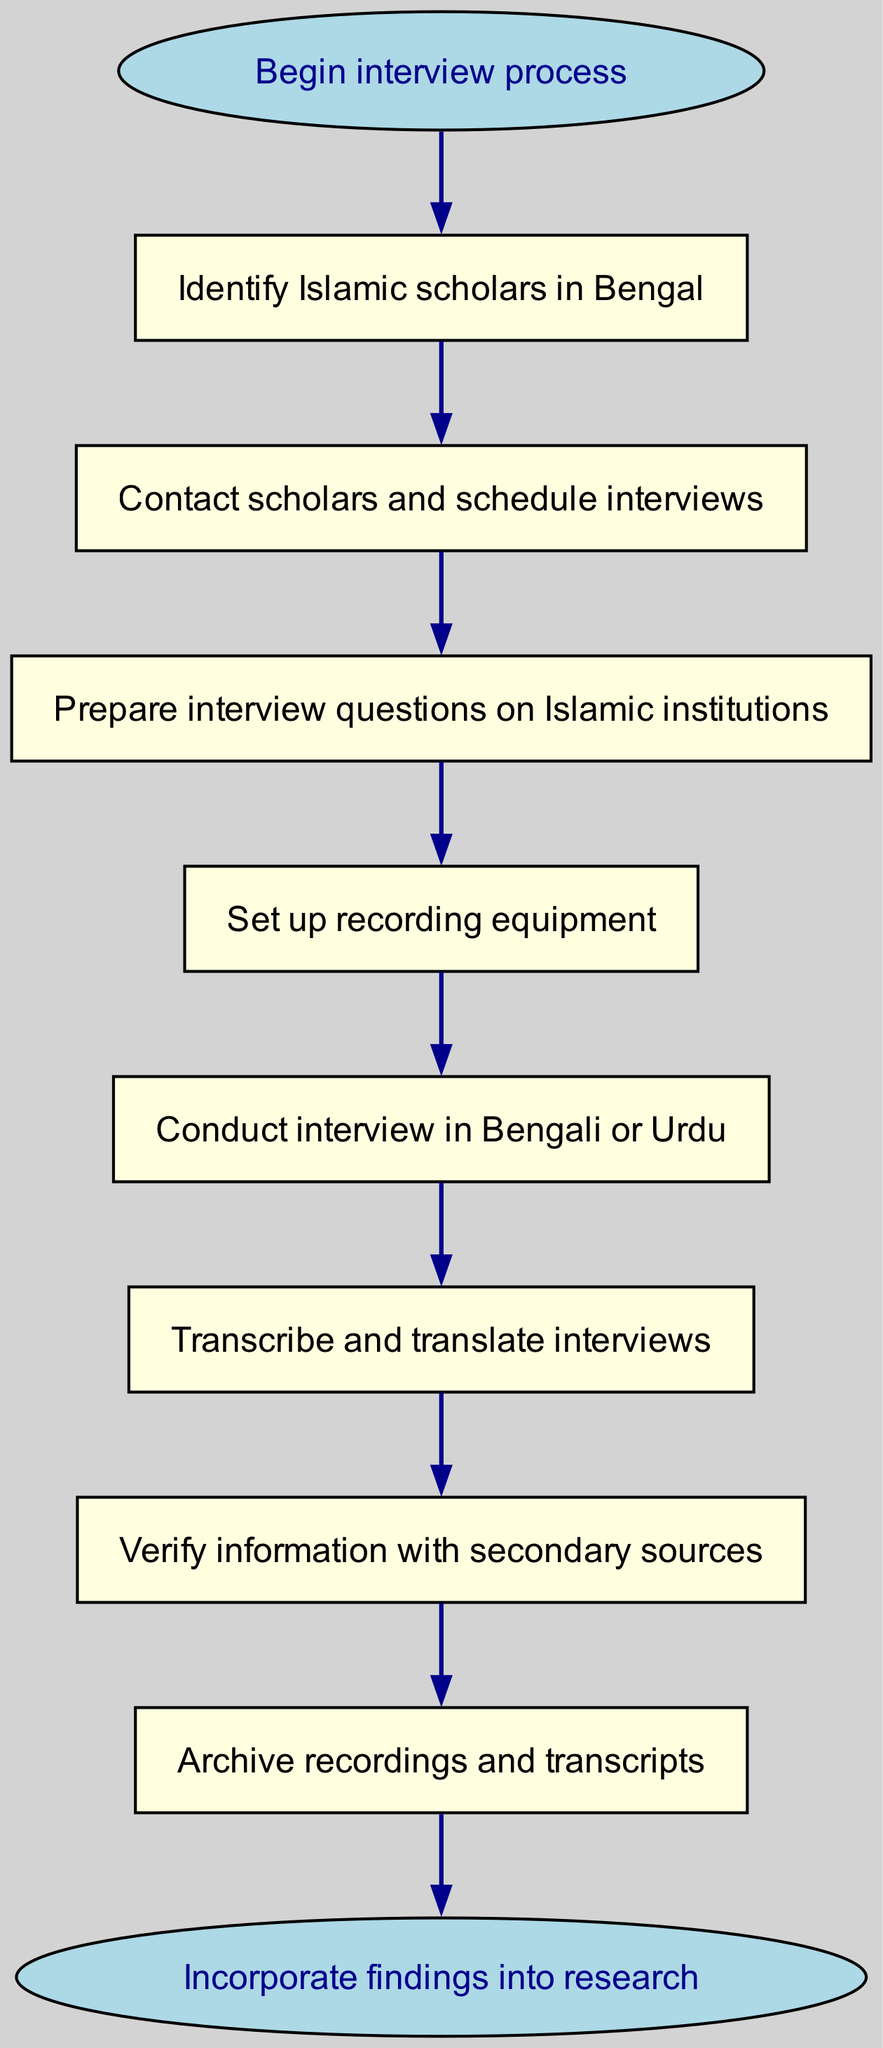What is the first step in the interview process? The diagram shows that the first step in the interview process is to "Identify Islamic scholars in Bengal," which is represented by the node labeled with that text.
Answer: Identify Islamic scholars in Bengal How many nodes are present in the diagram? By counting all the unique steps in the diagram, including the start and end nodes, we find there are a total of nine nodes in the flowchart.
Answer: Nine Which node follows "Set up recording equipment"? In the flow of the diagram, the node that follows "Set up recording equipment" is "Conduct interview in Bengali or Urdu," indicating the sequence of tasks.
Answer: Conduct interview in Bengali or Urdu What is the last action before archiving recordings and transcripts? The last action that occurs before archiving is "Verify information with secondary sources," which denotes the process taken to ensure accuracy prior to archiving.
Answer: Verify information with secondary sources What is the relationship between "Contact scholars and schedule interviews" and "Prepare interview questions on Islamic institutions"? The flowchart shows that "Contact scholars and schedule interviews" is a prerequisite to "Prepare interview questions on Islamic institutions," indicating a sequential relationship where one step must happen before the next.
Answer: Sequential relationship What is the overall process flow from start to end? Analyzing the flow in the diagram, the overall process begins with identifying scholars, moves through contacting them, preparing questions, conducting interviews, transcribing, verifying, archiving, and culminates in incorporating findings into research. Hence, it represents a linear progression from start to end.
Answer: Linear progression from identifying scholars to incorporating findings into research 